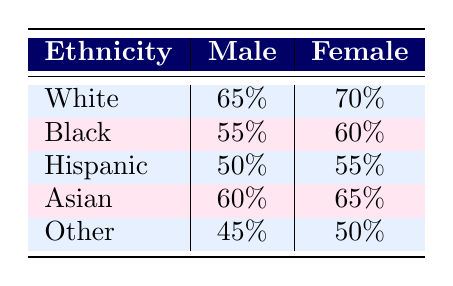What is the screening rate for White females? From the table, the screening rate for White females is directly listed under the Female column for the White ethnicity, which shows 70%.
Answer: 70% Which gender has a higher screening rate among Black individuals? Looking at the Black row, the screening rate for Black males is 55% and for Black females is 60%. Since 60% (female) is greater than 55% (male), females have a higher screening rate.
Answer: Female What is the difference in screening rates between Hispanic males and females? For Hispanic males, the screening rate is 50%, and for Hispanic females, it is 55%. The difference can be calculated as 55% - 50%, which equals 5%.
Answer: 5% Is the screening rate for Asian males higher than that for Black females? The screening rate for Asian males is 60% while the rate for Black females is 60% as well. Since the two rates are equal, the statement is false.
Answer: No What is the average screening rate for males across all ethnicities? We sum the screening rates for males (65% + 55% + 50% + 60% + 45%) which equals 275%. There are 5 male groups, so we divide 275% by 5, which gives an average screening rate of 55%.
Answer: 55% Which ethnicity has the lowest female screening rate? In the table, the only values for female screening rates are 70% (White), 60% (Black), 55% (Hispanic), 65% (Asian), and 50% (Other). The lowest value is for Other at 50%.
Answer: Other What percentage of Black females screened is below the average screening rate of 55% for males? The rate for Black females is 60%. Since 60% is above 55%, no percentage of Black females screened is below that average.
Answer: No What is the summed screening rate for all females in the dataset? To find the summed screening rate for females, we add the screening rates for females (70% + 60% + 55% + 65% + 50%) which equals 400%.
Answer: 400% 